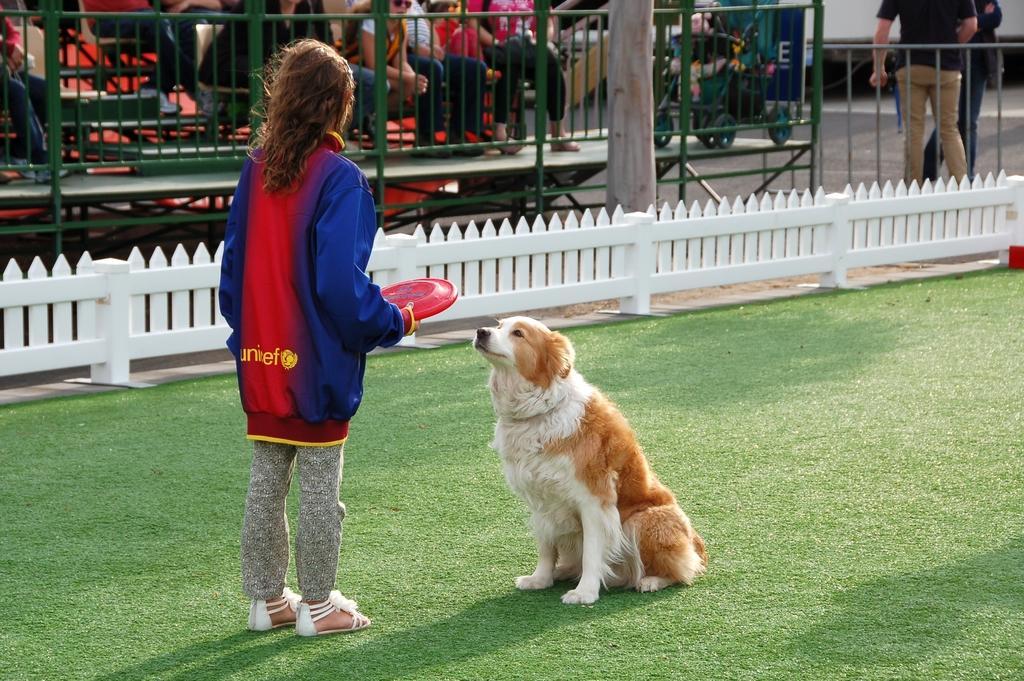Can you describe this image briefly? Here I can see a girl wearing a jacket, standing and holding a red color disc in the hand. In front of her a dog is sitting on the ground and looking at the girl. On the ground, I can see the grass. In the background there is a railing and a tree trunk. Behind the railing there are many people sitting. In the top right there are two persons standing on the ground. 